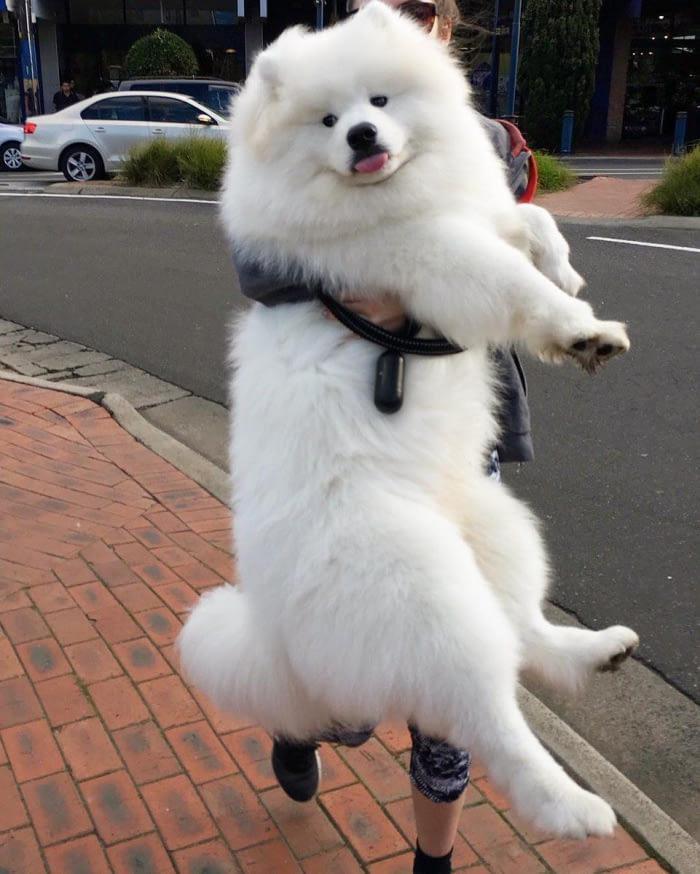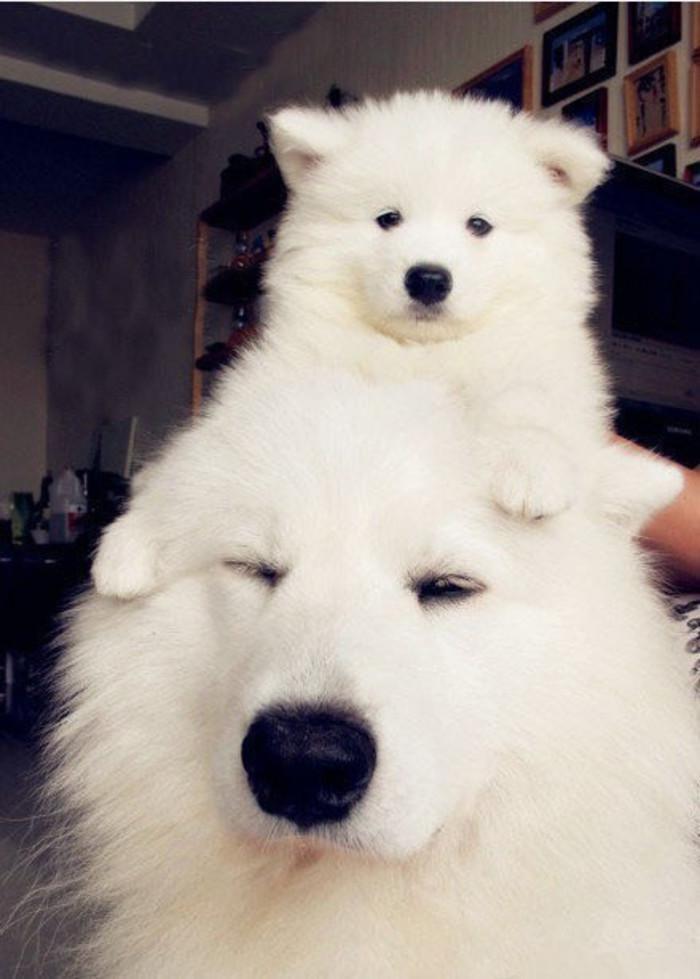The first image is the image on the left, the second image is the image on the right. Examine the images to the left and right. Is the description "There are exactly three dogs in total." accurate? Answer yes or no. Yes. The first image is the image on the left, the second image is the image on the right. Considering the images on both sides, is "Two white dogs are playing with a toy." valid? Answer yes or no. No. 